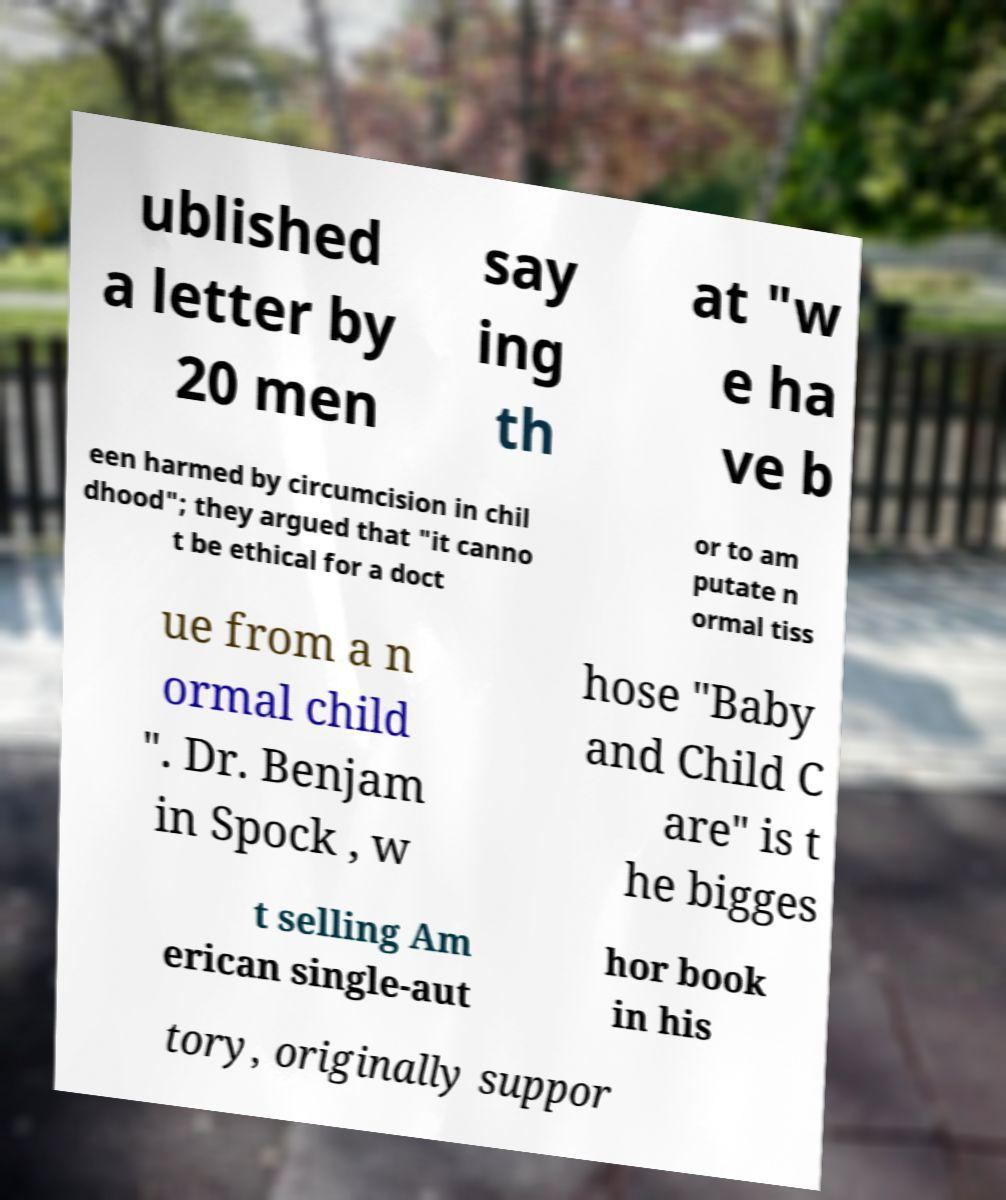I need the written content from this picture converted into text. Can you do that? ublished a letter by 20 men say ing th at "w e ha ve b een harmed by circumcision in chil dhood"; they argued that "it canno t be ethical for a doct or to am putate n ormal tiss ue from a n ormal child ". Dr. Benjam in Spock , w hose "Baby and Child C are" is t he bigges t selling Am erican single-aut hor book in his tory, originally suppor 